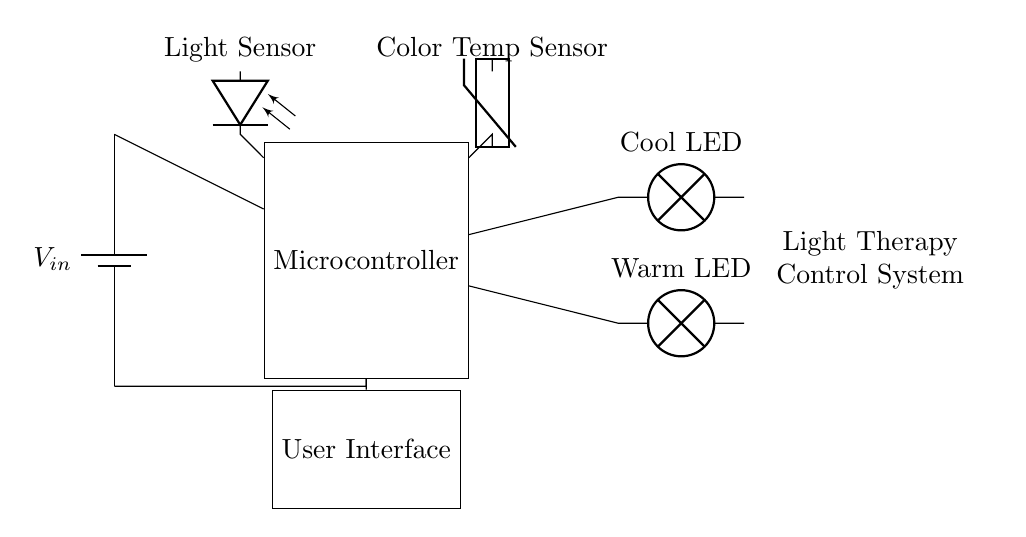What components are connected to the microcontroller? The components connected to the microcontroller include a light sensor, a color temperature sensor, a cool LED lamp, a warm LED lamp, and a user interface. Each is represented by a line connecting to the microcontroller symbol in the circuit.
Answer: light sensor, color temperature sensor, cool LED, warm LED, user interface What is the purpose of the light sensor? The light sensor's purpose is to detect ambient light conditions. In the circuit, it is depicted as connected to the microcontroller, indicating that it supplies the microcontroller with information about the current light levels.
Answer: detect ambient light What type of output does the microcontroller provide to the LED lamps? The microcontroller provides Pulse Width Modulation (PWM) outputs to control the intensity of the LED lamps. This is inferred from the connection lines and the fact that adjustable intensity implies a modulation technique like PWM is being used.
Answer: PWM How many LED lamps are shown in the circuit? There are two LED lamps shown in the circuit: one labeled as a cool LED and another labeled as a warm LED. Each lamp is represented separately in the diagram with distinct labels.
Answer: two What type of sensors are used in this circuit? The circuit uses a light sensor and a color temperature sensor. These sensors are indicated by their respective symbols and connected to the microcontroller for processing.
Answer: photodiode, thermistor Why is the user interface included in the circuit? The user interface is included to allow users to interact with the system, such as adjusting the light intensity and color temperature. It is connected to the microcontroller, indicating it plays a key role in user control.
Answer: user control What is the power supply voltage denoted by? The power supply voltage is denoted by V in, which represents the input voltage to the system. It is shown as the connection from the battery component at the starting point of the circuit diagram.
Answer: V in 